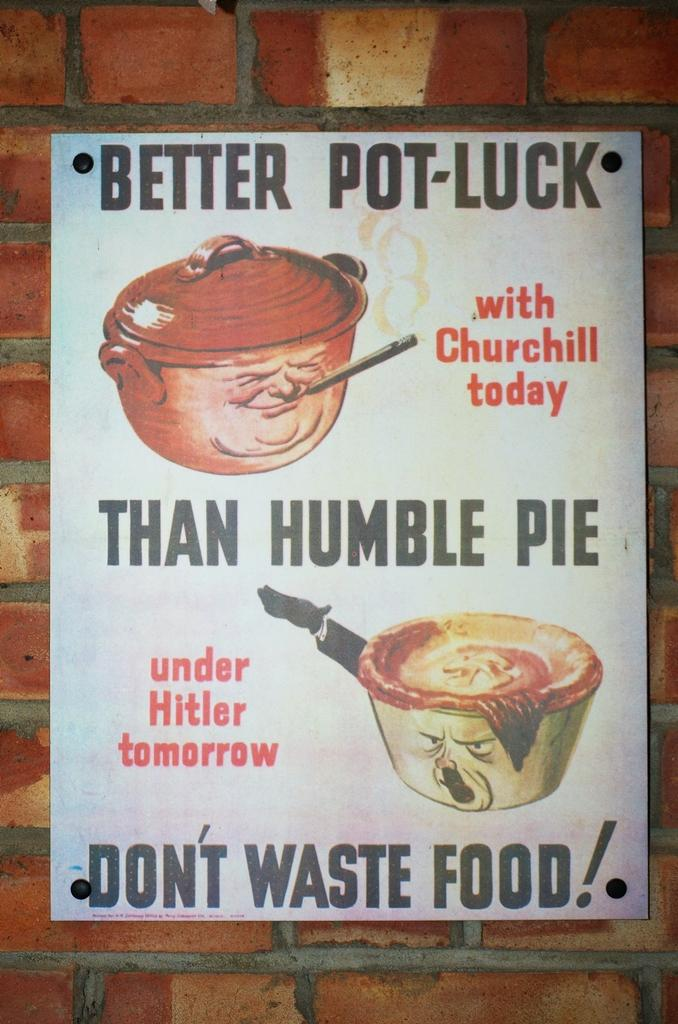What is featured on the poster in the image? The poster contains images and text. What type of surface is the poster attached to? The poster is on a brick wall. Can you see anyone jumping in front of the poster in the image? There is no one jumping in front of the poster in the image. Are there any icicles hanging from the poster in the image? There are no icicles present in the image. 